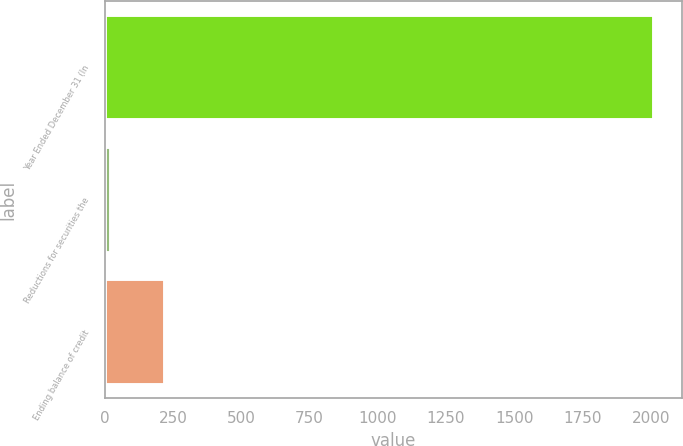Convert chart. <chart><loc_0><loc_0><loc_500><loc_500><bar_chart><fcel>Year Ended December 31 (In<fcel>Reductions for securities the<fcel>Ending balance of credit<nl><fcel>2013<fcel>23<fcel>222<nl></chart> 